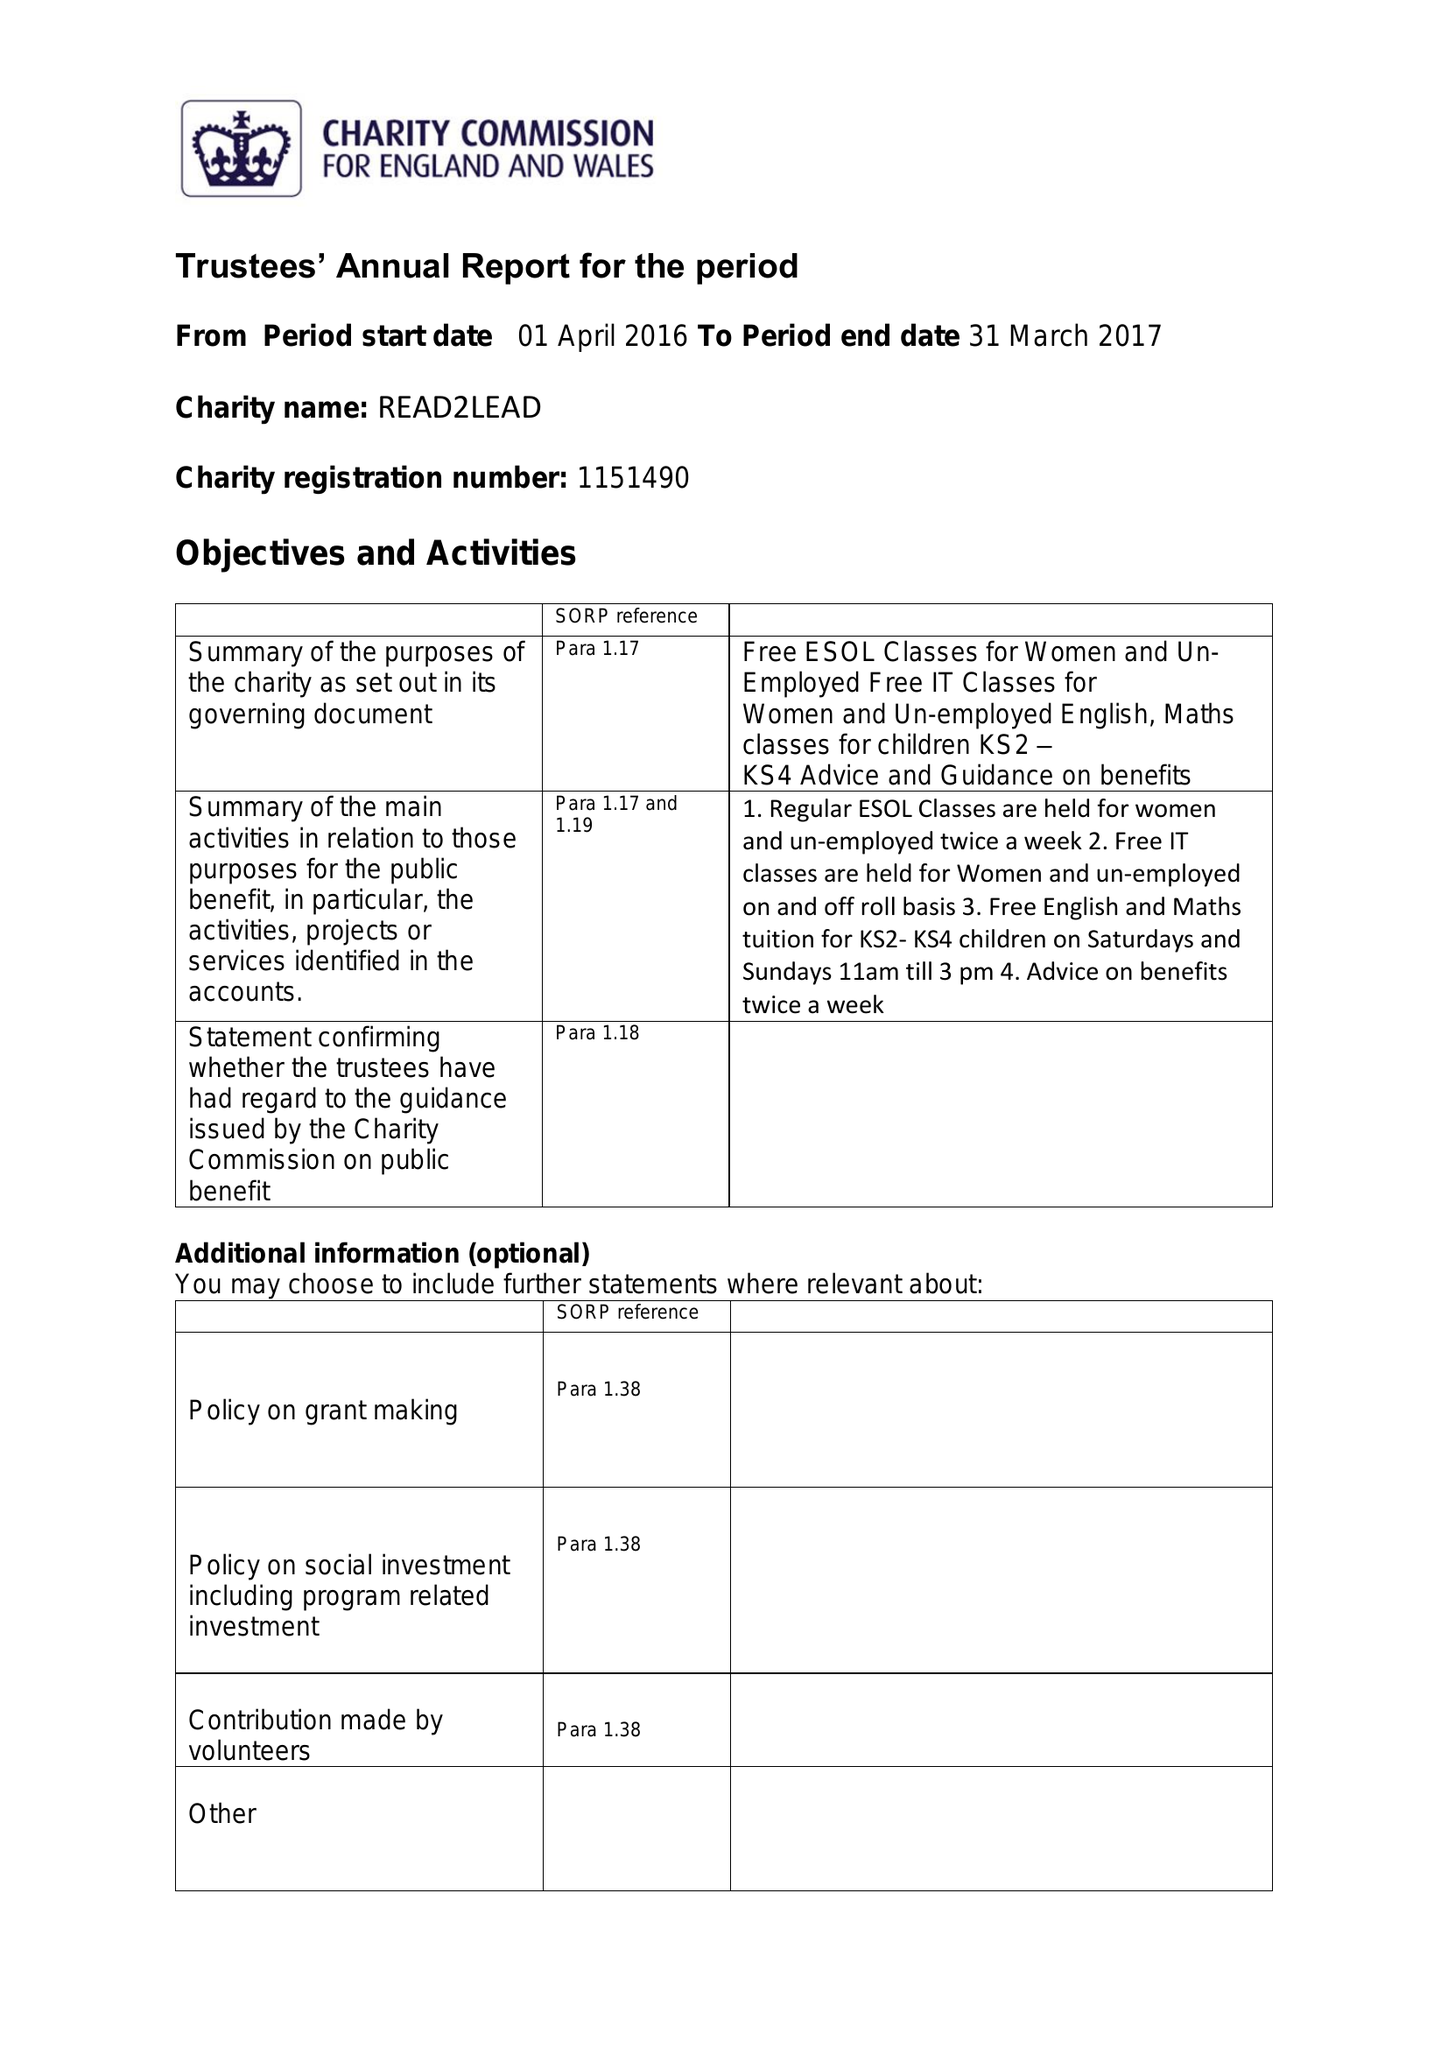What is the value for the address__street_line?
Answer the question using a single word or phrase. 43-45 WASHWOOD HEATH ROAD 